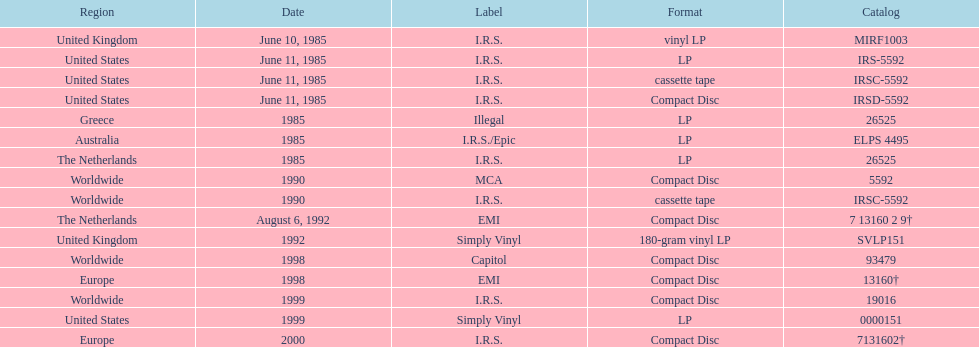In which year were the most releases? 1985. 